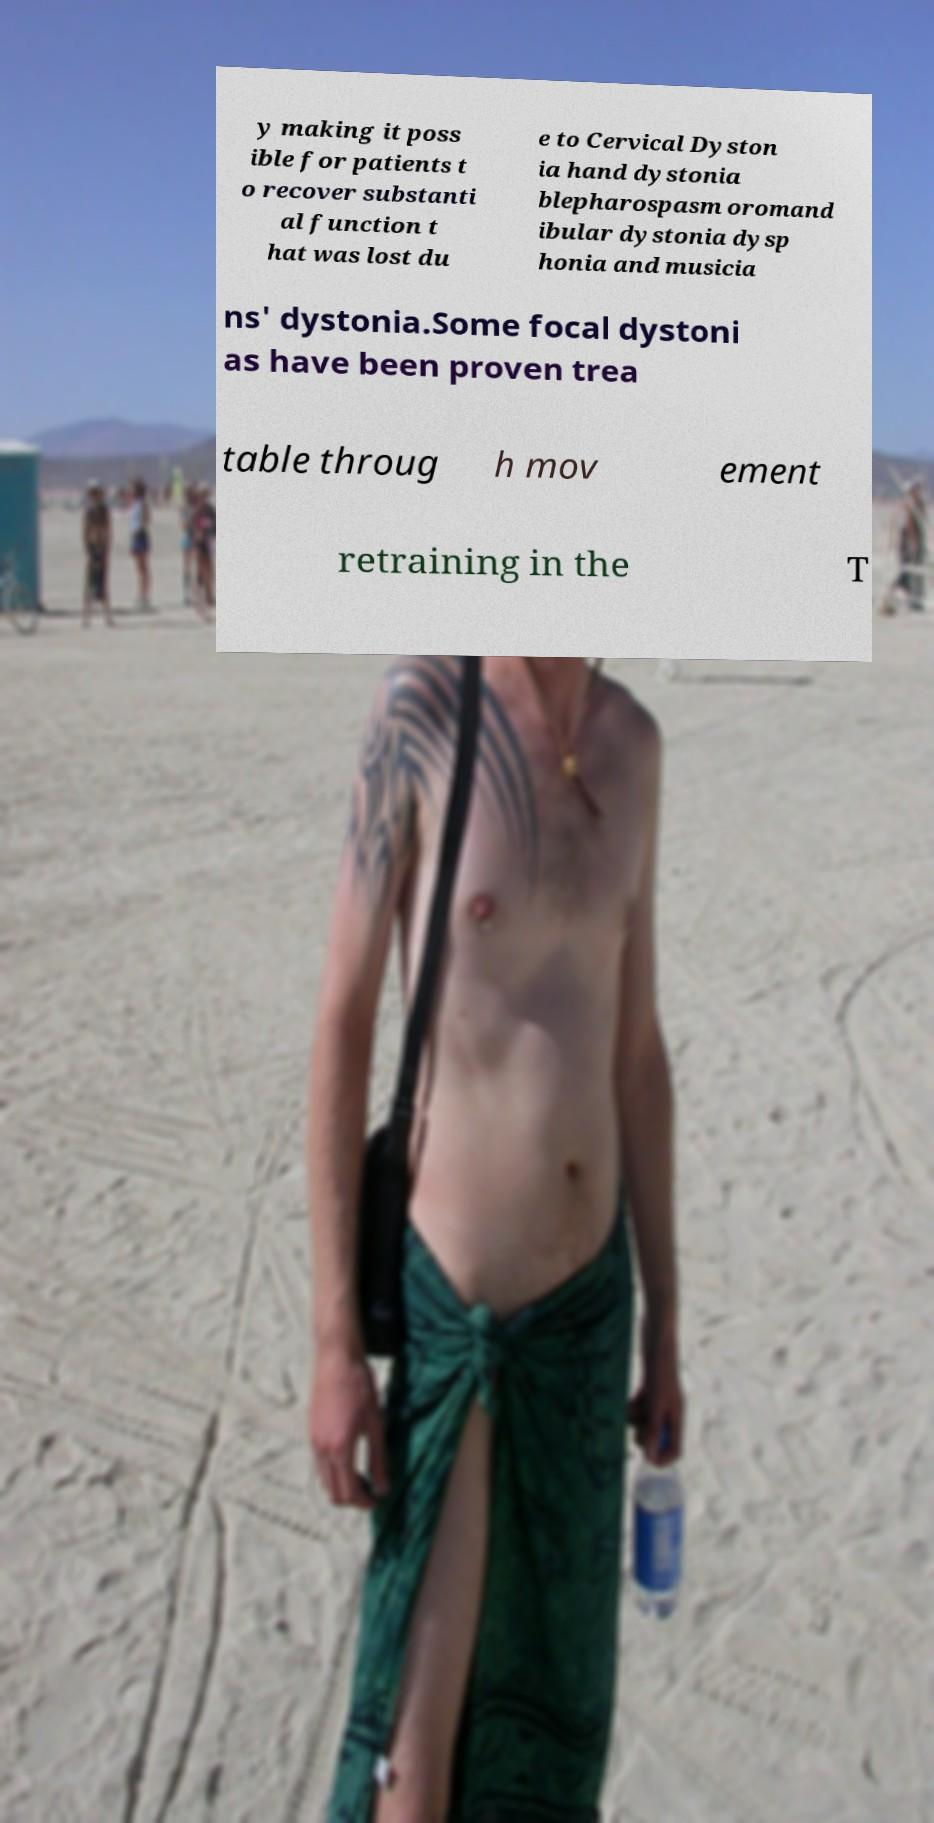Can you read and provide the text displayed in the image?This photo seems to have some interesting text. Can you extract and type it out for me? y making it poss ible for patients t o recover substanti al function t hat was lost du e to Cervical Dyston ia hand dystonia blepharospasm oromand ibular dystonia dysp honia and musicia ns' dystonia.Some focal dystoni as have been proven trea table throug h mov ement retraining in the T 